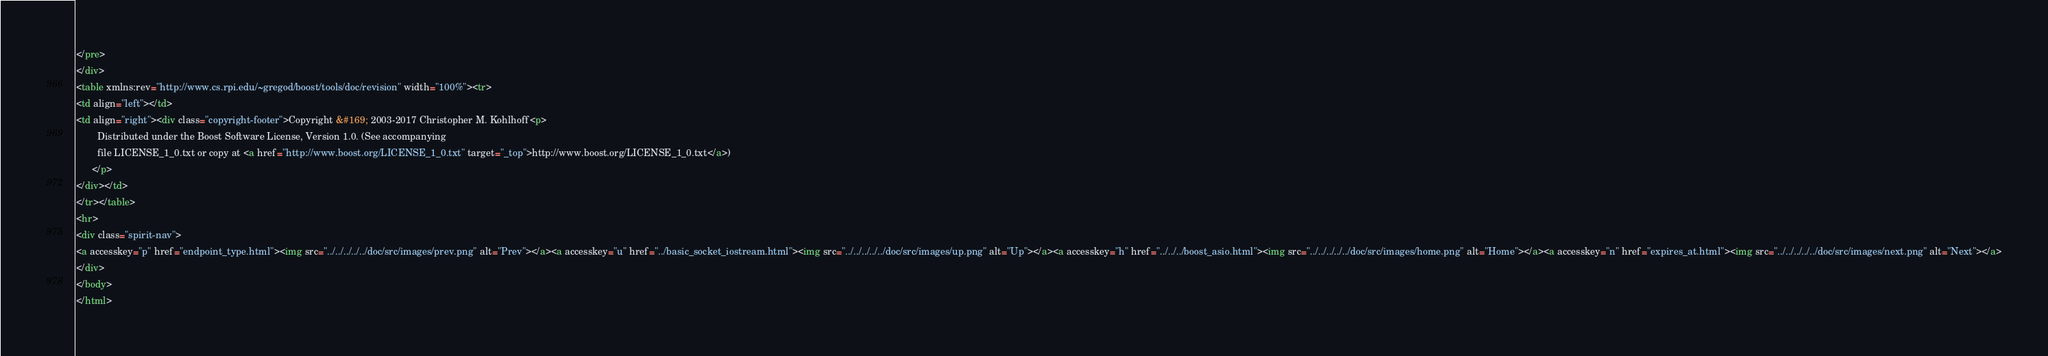<code> <loc_0><loc_0><loc_500><loc_500><_HTML_></pre>
</div>
<table xmlns:rev="http://www.cs.rpi.edu/~gregod/boost/tools/doc/revision" width="100%"><tr>
<td align="left"></td>
<td align="right"><div class="copyright-footer">Copyright &#169; 2003-2017 Christopher M. Kohlhoff<p>
        Distributed under the Boost Software License, Version 1.0. (See accompanying
        file LICENSE_1_0.txt or copy at <a href="http://www.boost.org/LICENSE_1_0.txt" target="_top">http://www.boost.org/LICENSE_1_0.txt</a>)
      </p>
</div></td>
</tr></table>
<hr>
<div class="spirit-nav">
<a accesskey="p" href="endpoint_type.html"><img src="../../../../../doc/src/images/prev.png" alt="Prev"></a><a accesskey="u" href="../basic_socket_iostream.html"><img src="../../../../../doc/src/images/up.png" alt="Up"></a><a accesskey="h" href="../../../boost_asio.html"><img src="../../../../../doc/src/images/home.png" alt="Home"></a><a accesskey="n" href="expires_at.html"><img src="../../../../../doc/src/images/next.png" alt="Next"></a>
</div>
</body>
</html>
</code> 